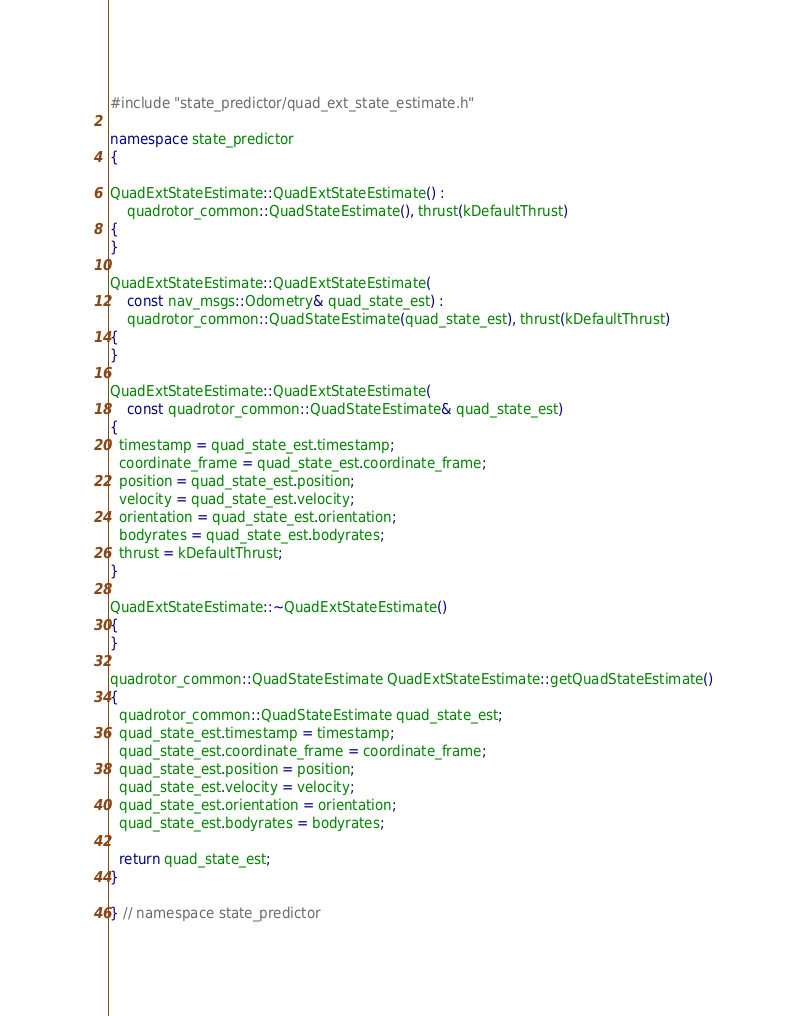Convert code to text. <code><loc_0><loc_0><loc_500><loc_500><_C++_>#include "state_predictor/quad_ext_state_estimate.h"

namespace state_predictor
{

QuadExtStateEstimate::QuadExtStateEstimate() :
    quadrotor_common::QuadStateEstimate(), thrust(kDefaultThrust)
{
}

QuadExtStateEstimate::QuadExtStateEstimate(
    const nav_msgs::Odometry& quad_state_est) :
    quadrotor_common::QuadStateEstimate(quad_state_est), thrust(kDefaultThrust)
{
}

QuadExtStateEstimate::QuadExtStateEstimate(
    const quadrotor_common::QuadStateEstimate& quad_state_est)
{
  timestamp = quad_state_est.timestamp;
  coordinate_frame = quad_state_est.coordinate_frame;
  position = quad_state_est.position;
  velocity = quad_state_est.velocity;
  orientation = quad_state_est.orientation;
  bodyrates = quad_state_est.bodyrates;
  thrust = kDefaultThrust;
}

QuadExtStateEstimate::~QuadExtStateEstimate()
{
}

quadrotor_common::QuadStateEstimate QuadExtStateEstimate::getQuadStateEstimate()
{
  quadrotor_common::QuadStateEstimate quad_state_est;
  quad_state_est.timestamp = timestamp;
  quad_state_est.coordinate_frame = coordinate_frame;
  quad_state_est.position = position;
  quad_state_est.velocity = velocity;
  quad_state_est.orientation = orientation;
  quad_state_est.bodyrates = bodyrates;

  return quad_state_est;
}

} // namespace state_predictor
</code> 